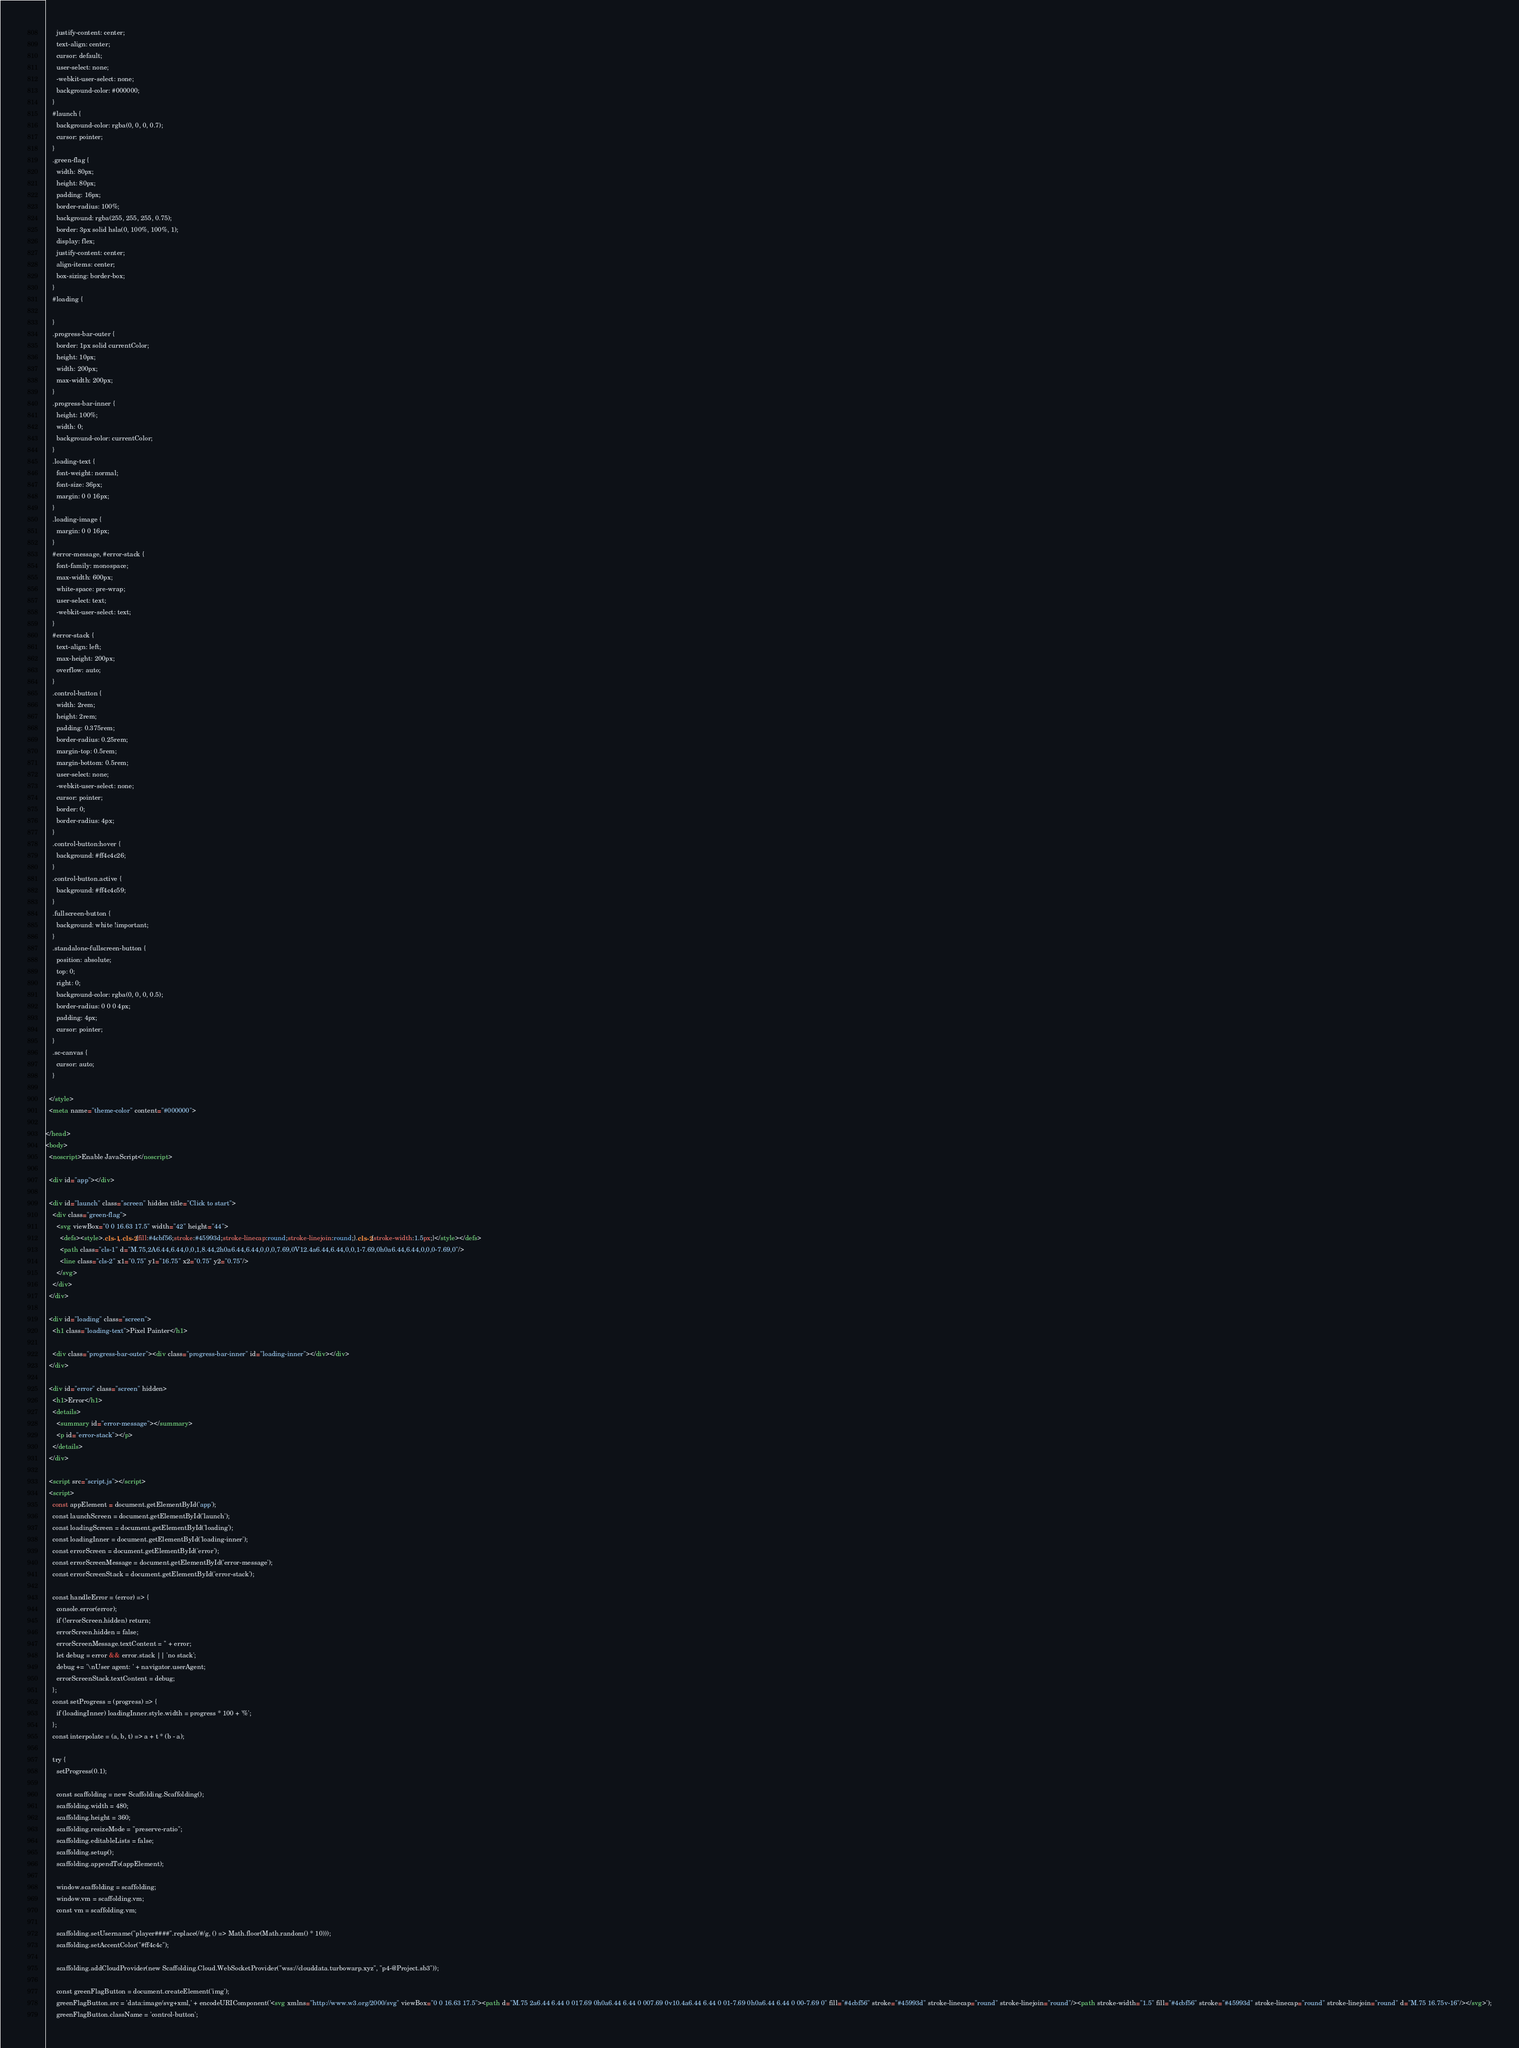<code> <loc_0><loc_0><loc_500><loc_500><_HTML_>      justify-content: center;
      text-align: center;
      cursor: default;
      user-select: none;
      -webkit-user-select: none;
      background-color: #000000;
    }
    #launch {
      background-color: rgba(0, 0, 0, 0.7);
      cursor: pointer;
    }
    .green-flag {
      width: 80px;
      height: 80px;
      padding: 16px;
      border-radius: 100%;
      background: rgba(255, 255, 255, 0.75);
      border: 3px solid hsla(0, 100%, 100%, 1);
      display: flex;
      justify-content: center;
      align-items: center;
      box-sizing: border-box;
    }
    #loading {
      
    }
    .progress-bar-outer {
      border: 1px solid currentColor;
      height: 10px;
      width: 200px;
      max-width: 200px;
    }
    .progress-bar-inner {
      height: 100%;
      width: 0;
      background-color: currentColor;
    }
    .loading-text {
      font-weight: normal;
      font-size: 36px;
      margin: 0 0 16px;
    }
    .loading-image {
      margin: 0 0 16px;
    }
    #error-message, #error-stack {
      font-family: monospace;
      max-width: 600px;
      white-space: pre-wrap;
      user-select: text;
      -webkit-user-select: text;
    }
    #error-stack {
      text-align: left;
      max-height: 200px;
      overflow: auto;
    }
    .control-button {
      width: 2rem;
      height: 2rem;
      padding: 0.375rem;
      border-radius: 0.25rem;
      margin-top: 0.5rem;
      margin-bottom: 0.5rem;
      user-select: none;
      -webkit-user-select: none;
      cursor: pointer;
      border: 0;
      border-radius: 4px;
    }
    .control-button:hover {
      background: #ff4c4c26;
    }
    .control-button.active {
      background: #ff4c4c59;
    }
    .fullscreen-button {
      background: white !important;
    }
    .standalone-fullscreen-button {
      position: absolute;
      top: 0;
      right: 0;
      background-color: rgba(0, 0, 0, 0.5);
      border-radius: 0 0 0 4px;
      padding: 4px;
      cursor: pointer;
    }
    .sc-canvas {
      cursor: auto;
    }
    
  </style>
  <meta name="theme-color" content="#000000">
  
</head>
<body>
  <noscript>Enable JavaScript</noscript>

  <div id="app"></div>

  <div id="launch" class="screen" hidden title="Click to start">
    <div class="green-flag">
      <svg viewBox="0 0 16.63 17.5" width="42" height="44">
        <defs><style>.cls-1,.cls-2{fill:#4cbf56;stroke:#45993d;stroke-linecap:round;stroke-linejoin:round;}.cls-2{stroke-width:1.5px;}</style></defs>
        <path class="cls-1" d="M.75,2A6.44,6.44,0,0,1,8.44,2h0a6.44,6.44,0,0,0,7.69,0V12.4a6.44,6.44,0,0,1-7.69,0h0a6.44,6.44,0,0,0-7.69,0"/>
        <line class="cls-2" x1="0.75" y1="16.75" x2="0.75" y2="0.75"/>
      </svg>
    </div>
  </div>

  <div id="loading" class="screen">
    <h1 class="loading-text">Pixel Painter</h1>
    
    <div class="progress-bar-outer"><div class="progress-bar-inner" id="loading-inner"></div></div>
  </div>

  <div id="error" class="screen" hidden>
    <h1>Error</h1>
    <details>
      <summary id="error-message"></summary>
      <p id="error-stack"></p>
    </details>
  </div>

  <script src="script.js"></script>
  <script>
    const appElement = document.getElementById('app');
    const launchScreen = document.getElementById('launch');
    const loadingScreen = document.getElementById('loading');
    const loadingInner = document.getElementById('loading-inner');
    const errorScreen = document.getElementById('error');
    const errorScreenMessage = document.getElementById('error-message');
    const errorScreenStack = document.getElementById('error-stack');

    const handleError = (error) => {
      console.error(error);
      if (!errorScreen.hidden) return;
      errorScreen.hidden = false;
      errorScreenMessage.textContent = '' + error;
      let debug = error && error.stack || 'no stack';
      debug += '\nUser agent: ' + navigator.userAgent;
      errorScreenStack.textContent = debug;
    };
    const setProgress = (progress) => {
      if (loadingInner) loadingInner.style.width = progress * 100 + '%';
    };
    const interpolate = (a, b, t) => a + t * (b - a);

    try {
      setProgress(0.1);

      const scaffolding = new Scaffolding.Scaffolding();
      scaffolding.width = 480;
      scaffolding.height = 360;
      scaffolding.resizeMode = "preserve-ratio";
      scaffolding.editableLists = false;
      scaffolding.setup();
      scaffolding.appendTo(appElement);

      window.scaffolding = scaffolding;
      window.vm = scaffolding.vm;
      const vm = scaffolding.vm;

      scaffolding.setUsername("player####".replace(/#/g, () => Math.floor(Math.random() * 10)));
      scaffolding.setAccentColor("#ff4c4c");

      scaffolding.addCloudProvider(new Scaffolding.Cloud.WebSocketProvider("wss://clouddata.turbowarp.xyz", "p4-@Project.sb3"));

      const greenFlagButton = document.createElement('img');
      greenFlagButton.src = 'data:image/svg+xml,' + encodeURIComponent('<svg xmlns="http://www.w3.org/2000/svg" viewBox="0 0 16.63 17.5"><path d="M.75 2a6.44 6.44 0 017.69 0h0a6.44 6.44 0 007.69 0v10.4a6.44 6.44 0 01-7.69 0h0a6.44 6.44 0 00-7.69 0" fill="#4cbf56" stroke="#45993d" stroke-linecap="round" stroke-linejoin="round"/><path stroke-width="1.5" fill="#4cbf56" stroke="#45993d" stroke-linecap="round" stroke-linejoin="round" d="M.75 16.75v-16"/></svg>');
      greenFlagButton.className = 'control-button';</code> 